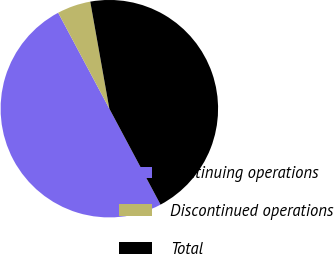<chart> <loc_0><loc_0><loc_500><loc_500><pie_chart><fcel>Continuing operations<fcel>Discontinued operations<fcel>Total<nl><fcel>50.0%<fcel>4.99%<fcel>45.01%<nl></chart> 